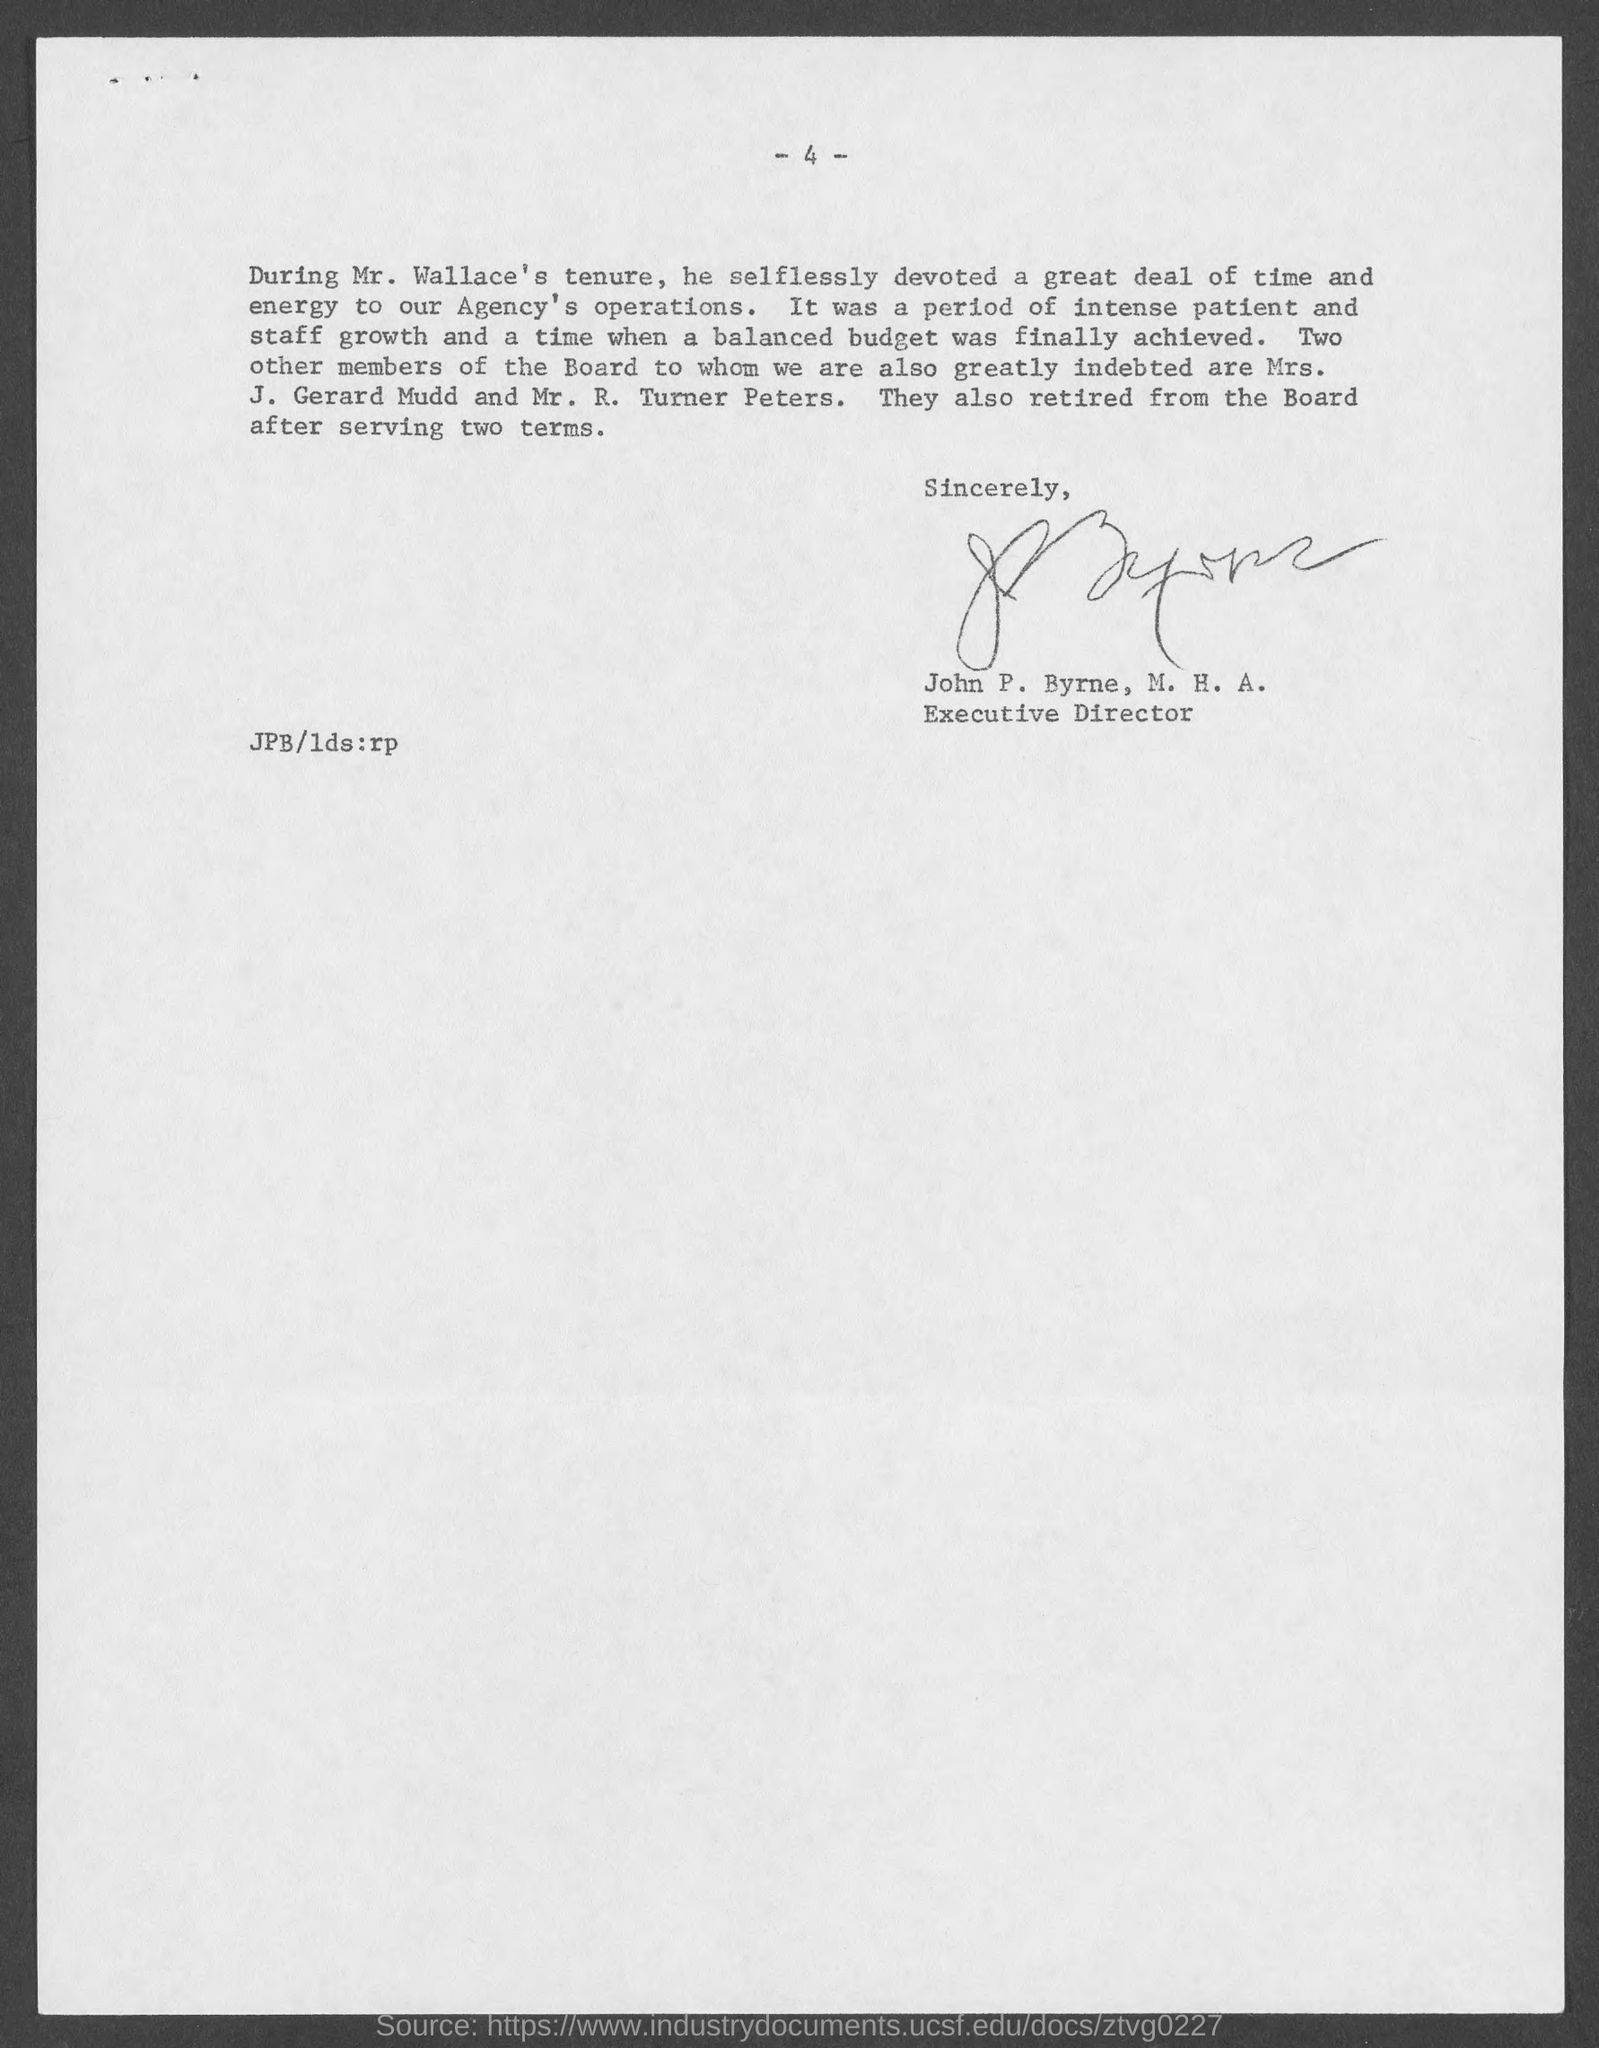Who are the members are indebted of the Board?
Your answer should be very brief. Mrs. J. Gerard Mudd and Mr. R. Turner Peters. 